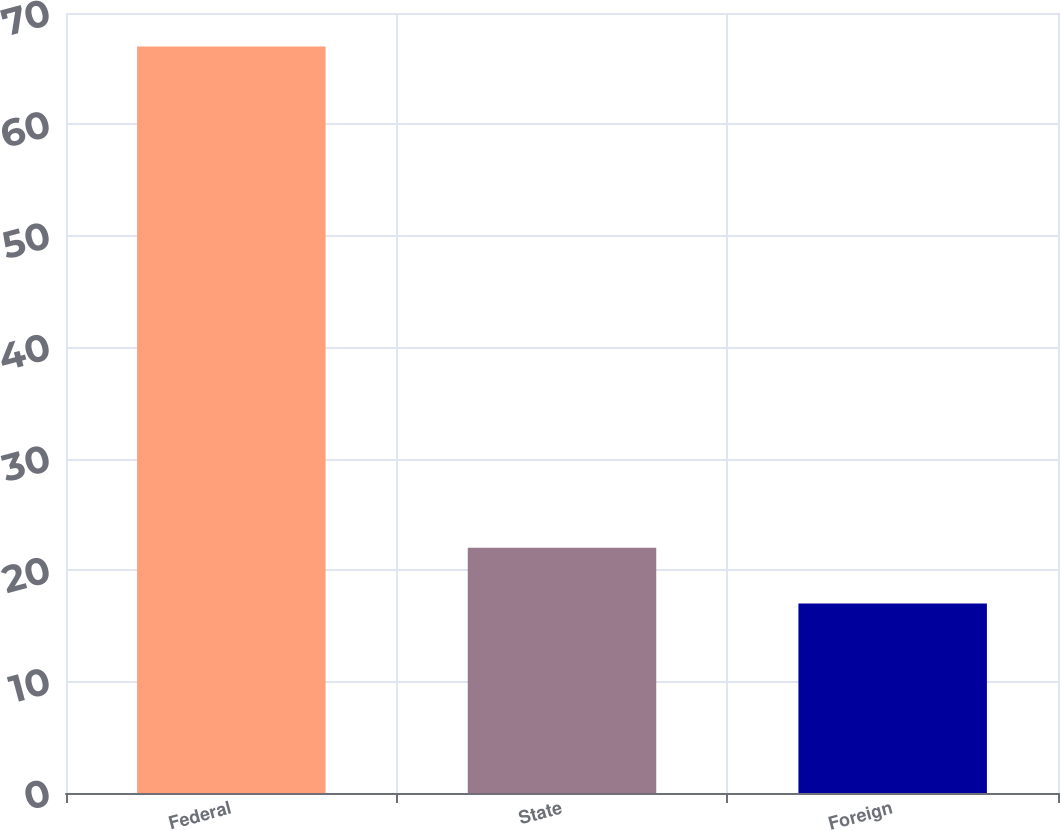<chart> <loc_0><loc_0><loc_500><loc_500><bar_chart><fcel>Federal<fcel>State<fcel>Foreign<nl><fcel>67<fcel>22<fcel>17<nl></chart> 